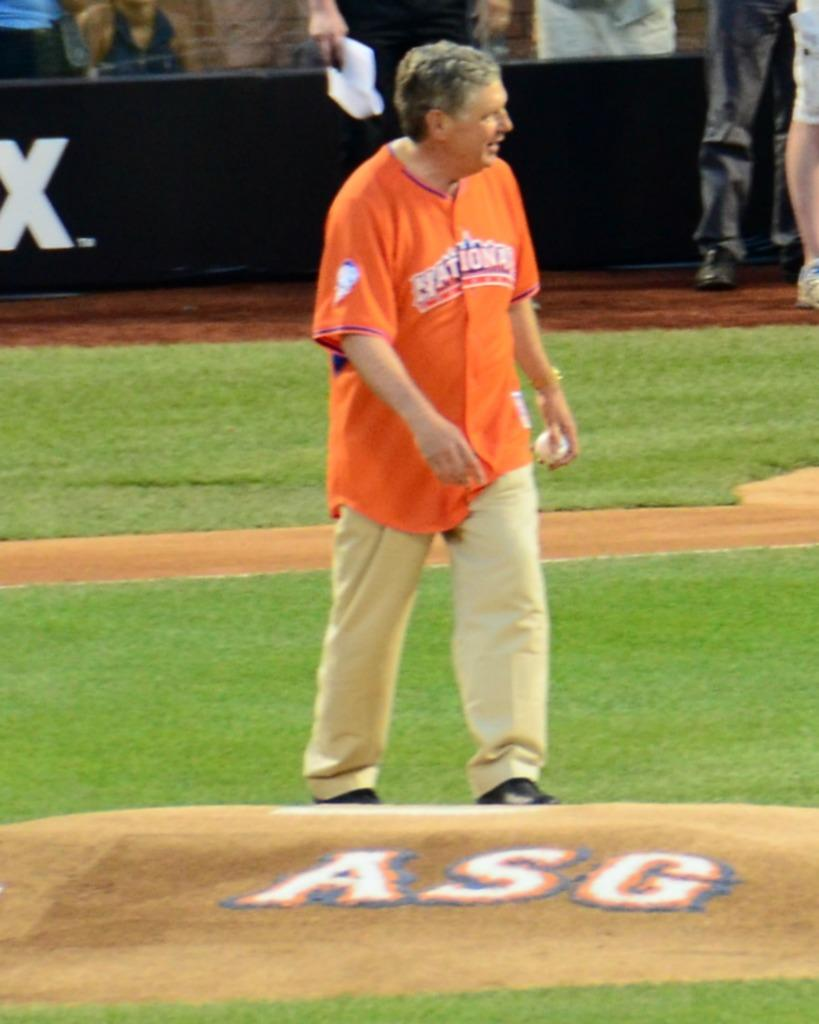<image>
Give a short and clear explanation of the subsequent image. a man that has a shirt on next to an ASG logo 